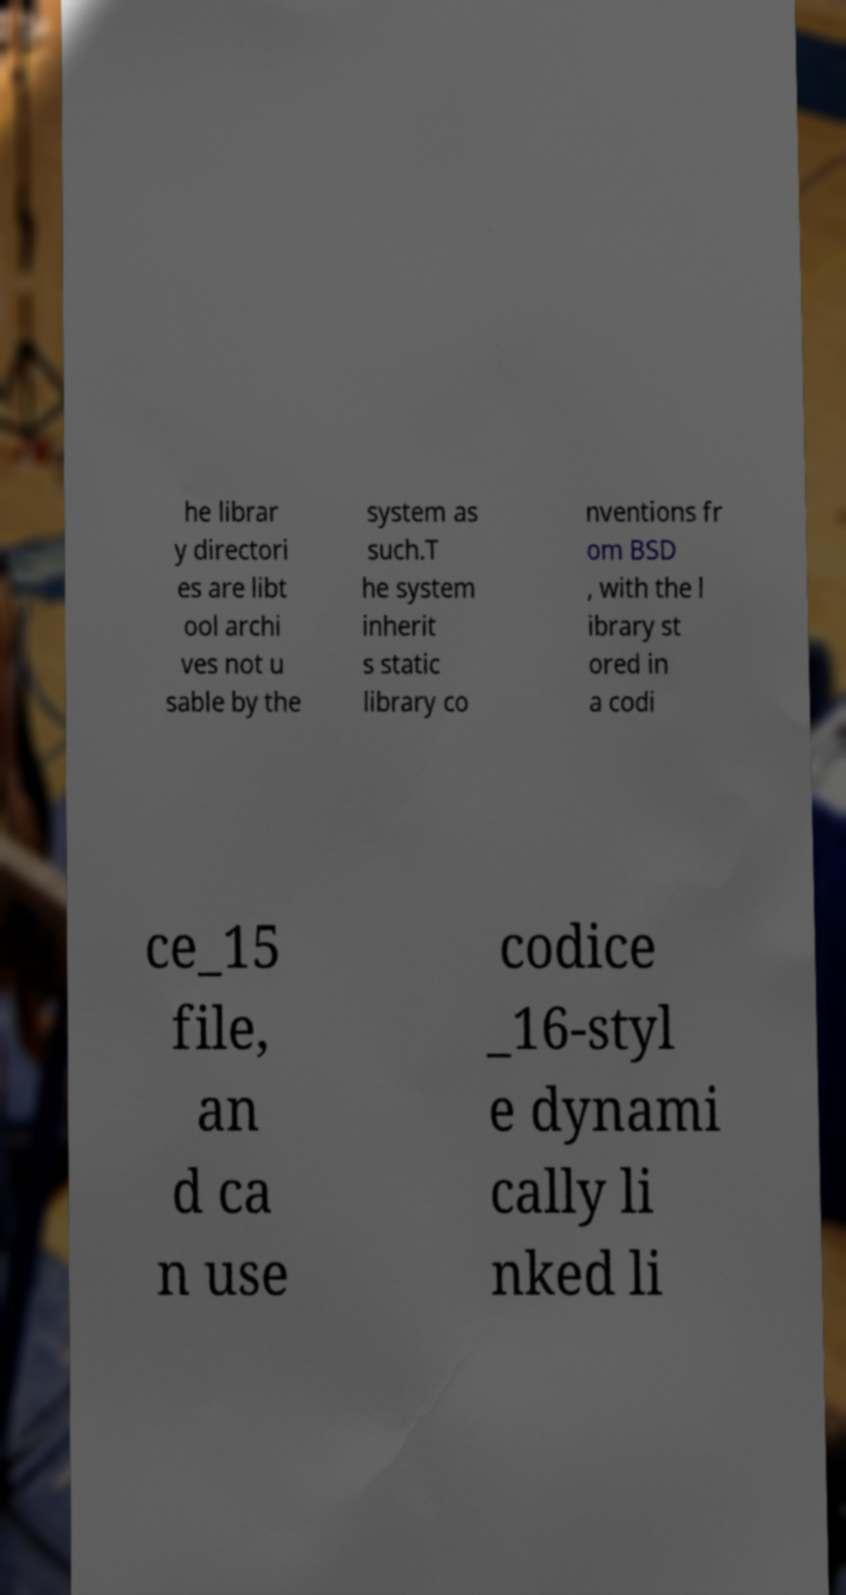What messages or text are displayed in this image? I need them in a readable, typed format. he librar y directori es are libt ool archi ves not u sable by the system as such.T he system inherit s static library co nventions fr om BSD , with the l ibrary st ored in a codi ce_15 file, an d ca n use codice _16-styl e dynami cally li nked li 